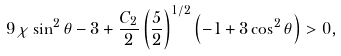Convert formula to latex. <formula><loc_0><loc_0><loc_500><loc_500>9 \chi \sin ^ { 2 } \theta - 3 + \frac { C _ { 2 } } { 2 } \left ( \frac { 5 } { 2 } \right ) ^ { 1 / 2 } \left ( - 1 + 3 \cos ^ { 2 } \theta \right ) > 0 ,</formula> 